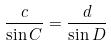Convert formula to latex. <formula><loc_0><loc_0><loc_500><loc_500>\frac { c } { \sin C } = \frac { d } { \sin D }</formula> 